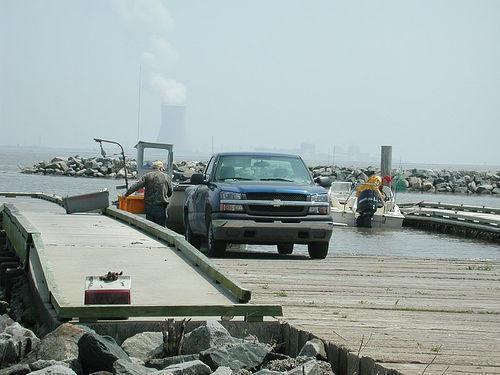What is the red and white box on the left used for?
Make your selection from the four choices given to correctly answer the question.
Options: Shipping, keeping cool, solving puzzles, collecting sand. Keeping cool. 